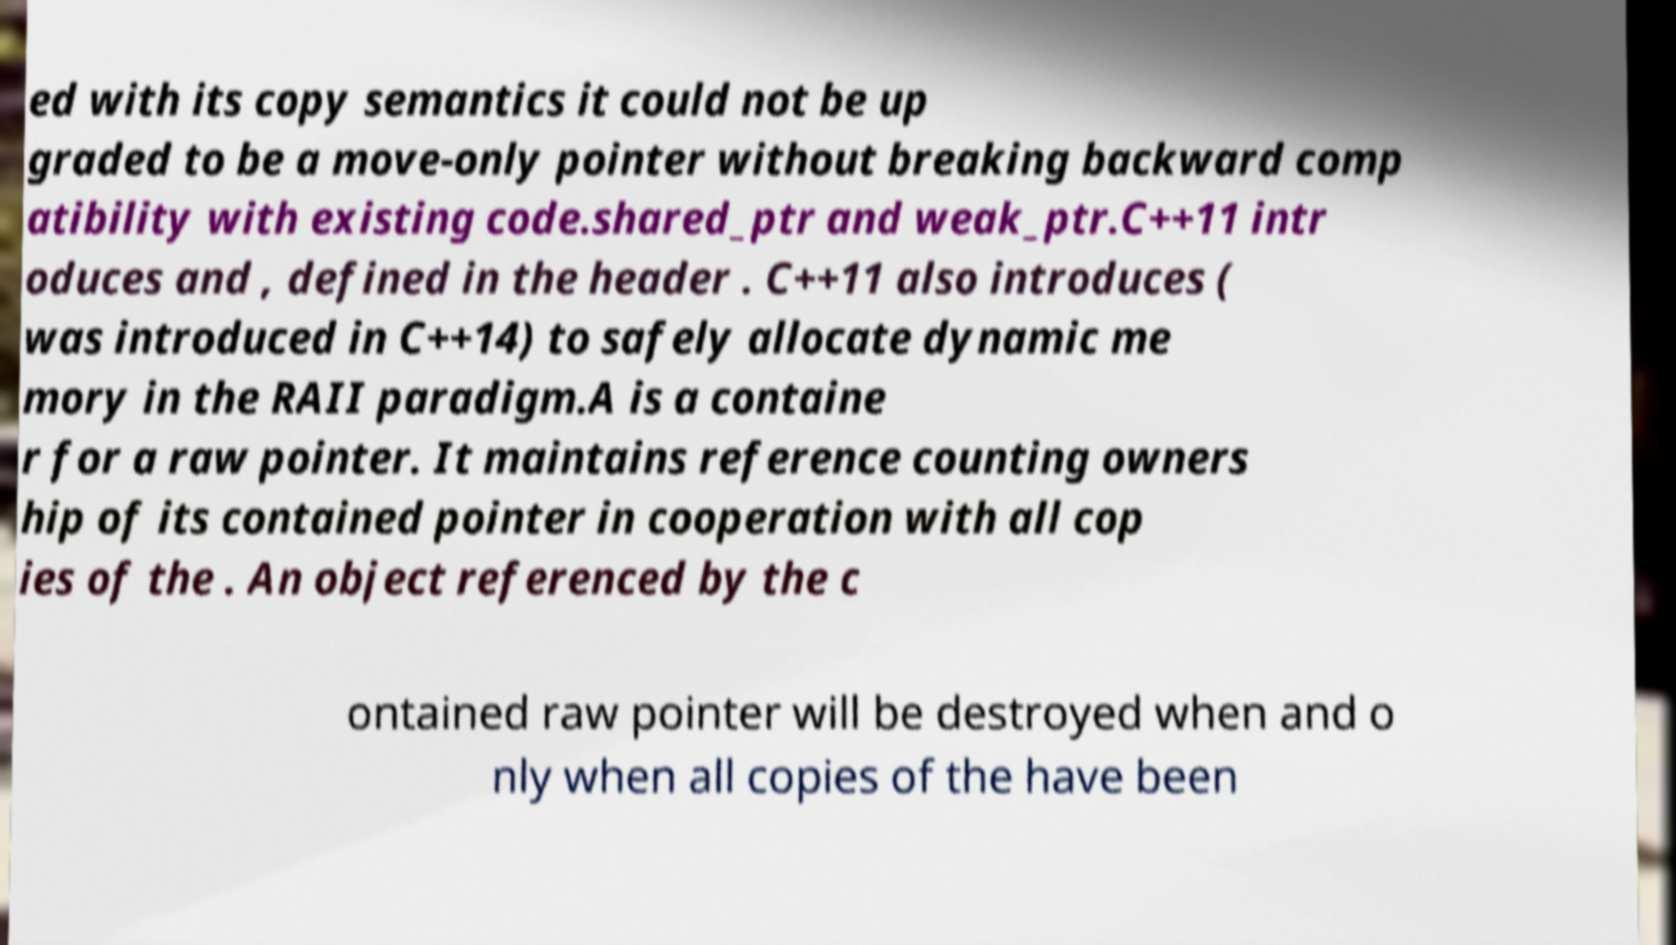There's text embedded in this image that I need extracted. Can you transcribe it verbatim? ed with its copy semantics it could not be up graded to be a move-only pointer without breaking backward comp atibility with existing code.shared_ptr and weak_ptr.C++11 intr oduces and , defined in the header . C++11 also introduces ( was introduced in C++14) to safely allocate dynamic me mory in the RAII paradigm.A is a containe r for a raw pointer. It maintains reference counting owners hip of its contained pointer in cooperation with all cop ies of the . An object referenced by the c ontained raw pointer will be destroyed when and o nly when all copies of the have been 